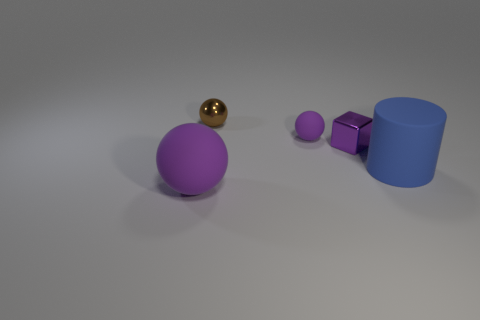What shape is the shiny thing that is behind the purple matte object behind the matte thing on the right side of the tiny purple cube?
Offer a terse response. Sphere. There is a matte ball that is in front of the blue rubber thing; does it have the same size as the large blue object?
Make the answer very short. Yes. There is a rubber thing that is both to the left of the purple metallic cube and in front of the tiny shiny cube; what shape is it?
Make the answer very short. Sphere. Is the color of the big matte cylinder the same as the tiny metal thing behind the block?
Your answer should be compact. No. What color is the thing that is in front of the large rubber thing behind the sphere that is in front of the blue matte thing?
Ensure brevity in your answer.  Purple. There is another matte thing that is the same shape as the tiny matte thing; what color is it?
Offer a very short reply. Purple. Are there an equal number of tiny metallic blocks that are in front of the blue cylinder and matte cylinders?
Ensure brevity in your answer.  No. How many blocks are either small purple metallic objects or big things?
Give a very brief answer. 1. The other thing that is the same material as the brown thing is what color?
Your answer should be compact. Purple. Do the brown ball and the tiny purple object that is in front of the tiny rubber ball have the same material?
Make the answer very short. Yes. 